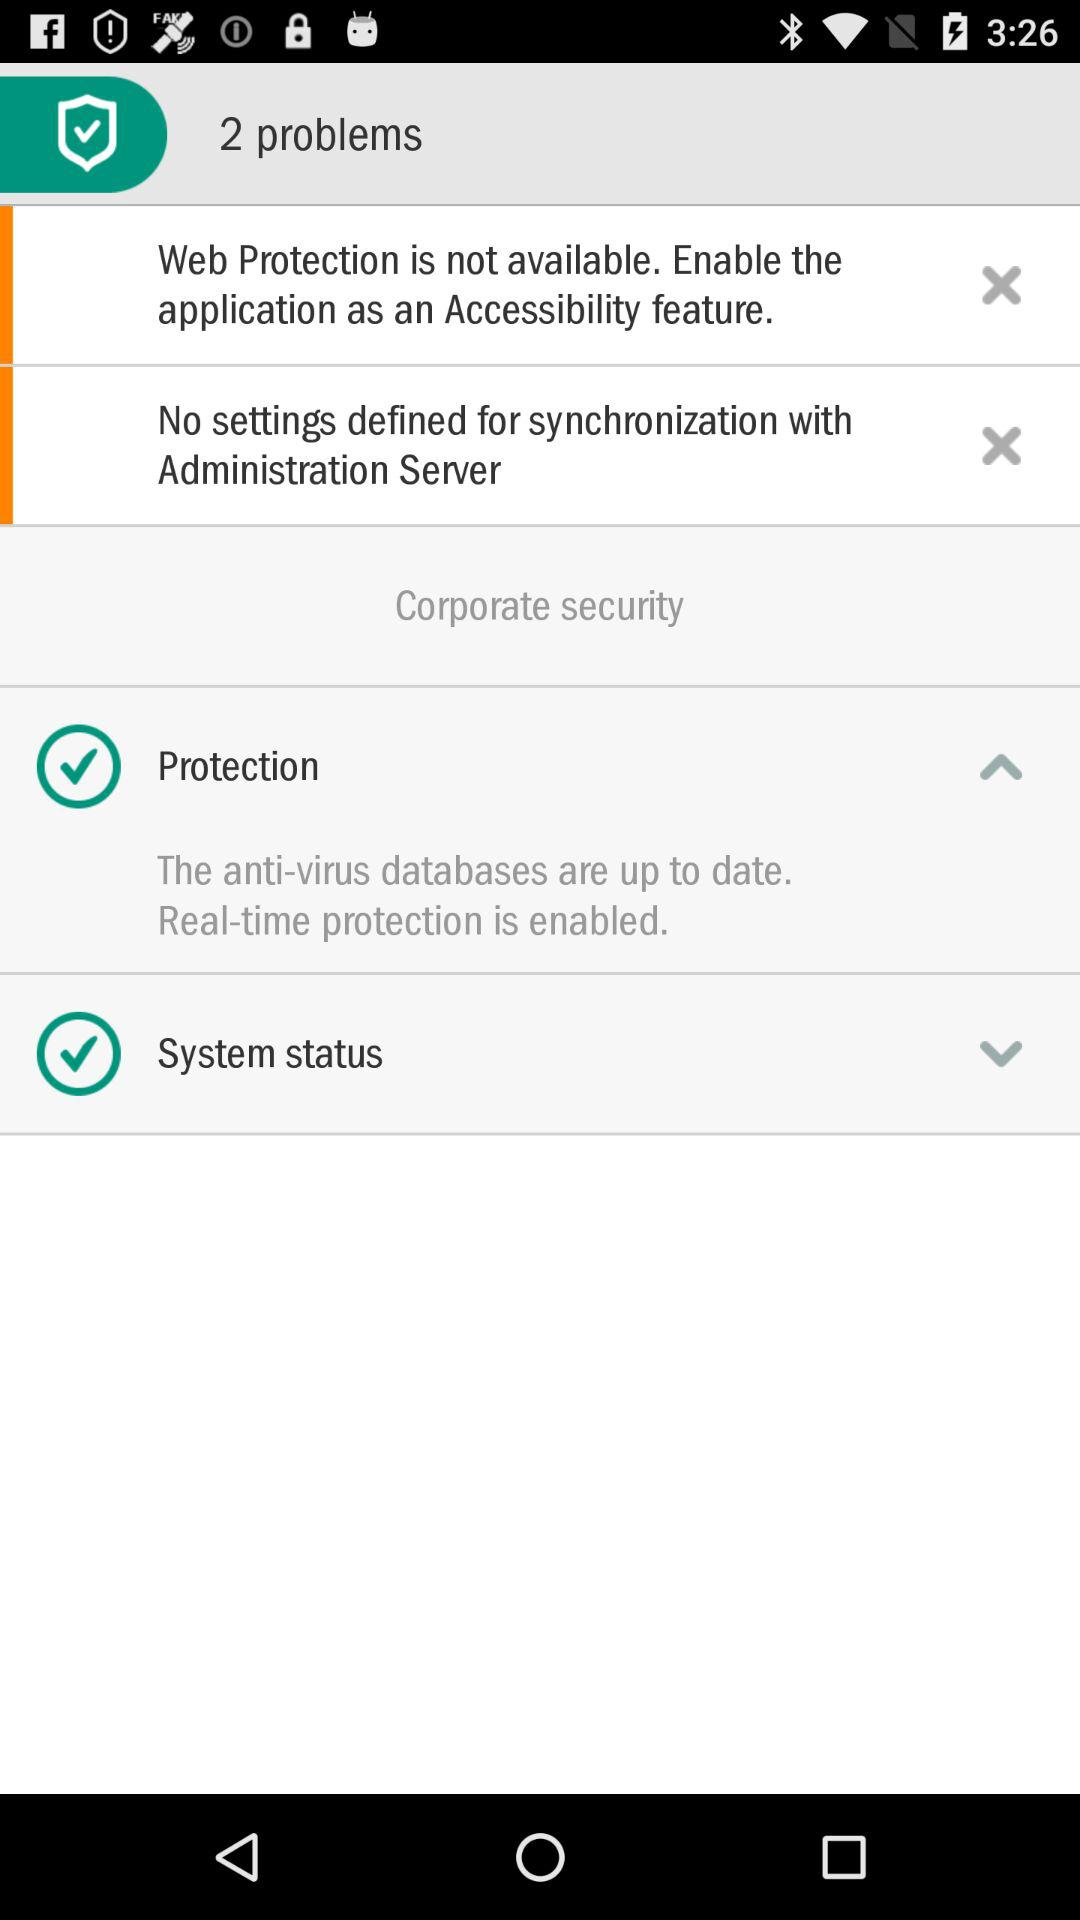What is corporate security? The corporate security is "Protection" and "System status". 